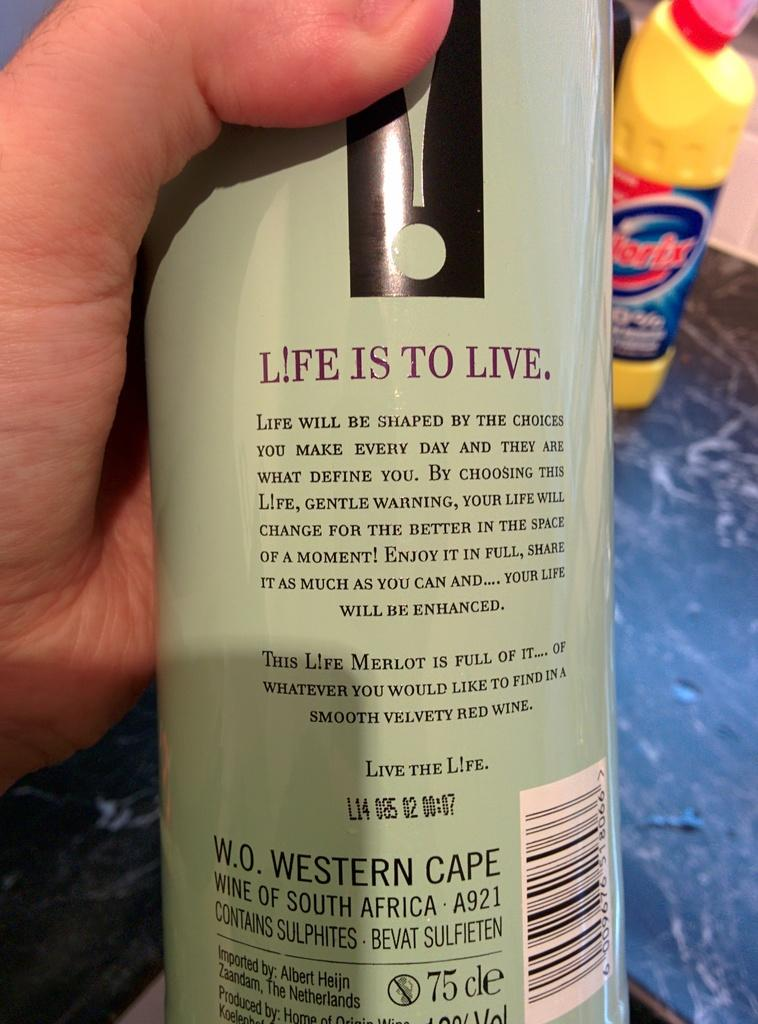<image>
Relay a brief, clear account of the picture shown. Back of bottle blurb that starts with L!FE IS TO LIVE 